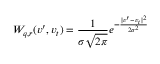Convert formula to latex. <formula><loc_0><loc_0><loc_500><loc_500>W _ { q , r } ( v ^ { \prime } , v _ { t } ) = \frac { 1 } { \sigma \sqrt { 2 \pi } } e ^ { - \frac { | v ^ { \prime } - v _ { t } | ^ { 2 } } { 2 \sigma ^ { 2 } } }</formula> 